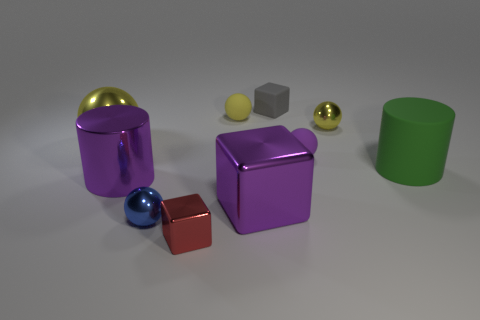Subtract all green blocks. How many yellow balls are left? 3 Subtract all cubes. How many objects are left? 7 Subtract all rubber balls. Subtract all large purple cubes. How many objects are left? 7 Add 2 matte spheres. How many matte spheres are left? 4 Add 3 tiny red balls. How many tiny red balls exist? 3 Subtract 0 cyan blocks. How many objects are left? 10 